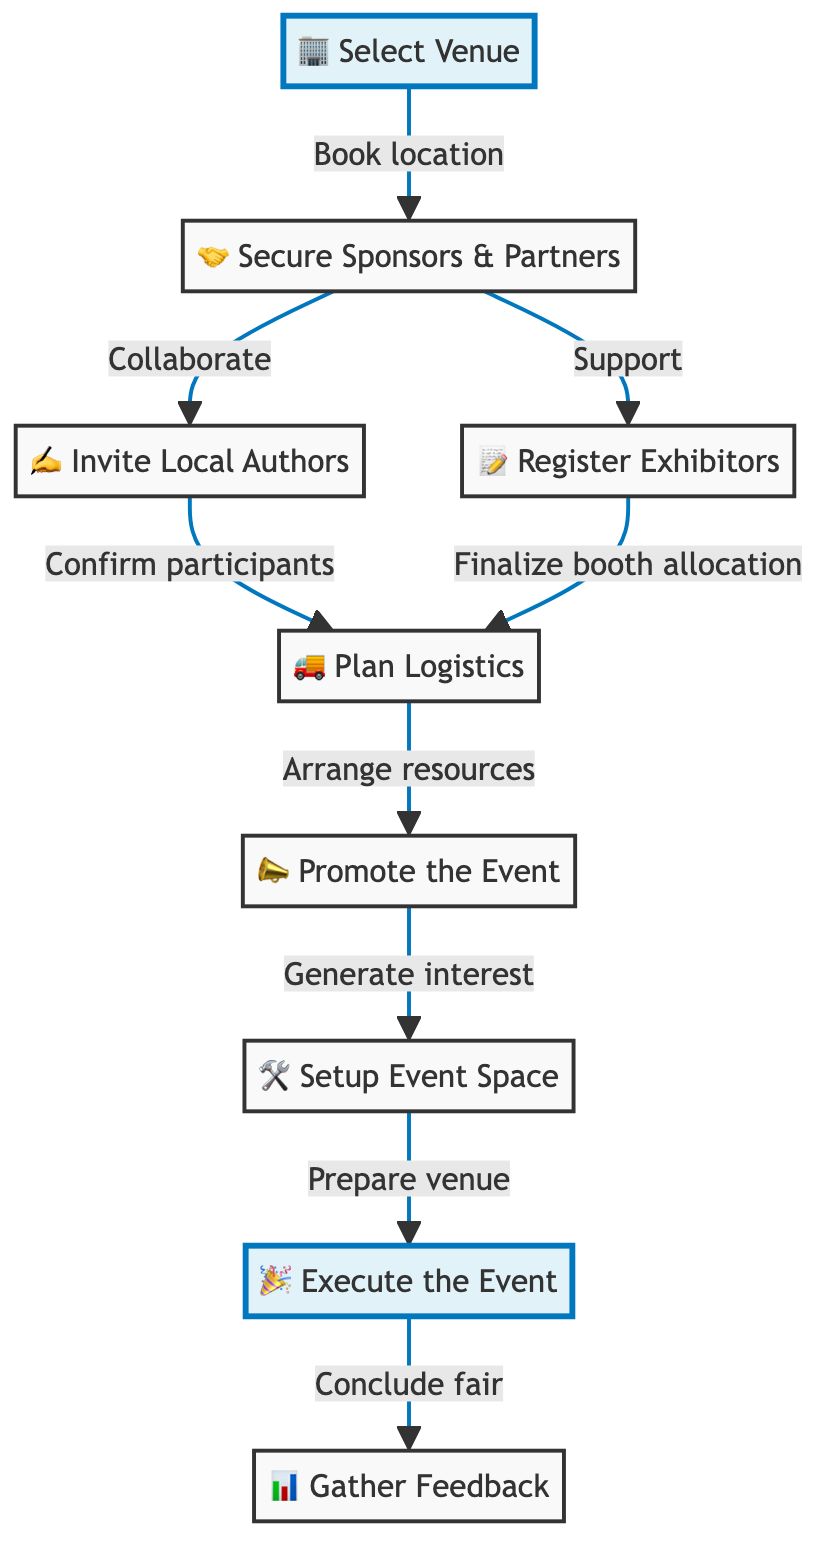What is the first step in the book fair setup process? The first step is "Select Venue," which involves identifying and booking a suitable location for the book fair.
Answer: Select Venue How many main nodes are there in the diagram? The diagram contains 9 main nodes, each representing a key step in the book fair setup process.
Answer: 9 Which step follows after securing sponsors and partners? After securing sponsors and partners, the next step is to "Invite Local Authors" to showcase their work at the fair.
Answer: Invite Local Authors What is the relationship between "Logistics Planning" and "Register Exhibitors"? Both "Logistics Planning" and "Register Exhibitors" are connected by the need to provide resources for setting up booths, indicating they occur simultaneously.
Answer: Arrange resources What is the final outcome of the event execution step? The final outcome of the "Execute the Event" step is to "Gather Feedback" from exhibitors and attendees for future improvements.
Answer: Gather Feedback Which step is highlighted in blue? The highlighted steps are "Select Venue" and "Execute the Event," indicating they are significant focal points in the process.
Answer: Select Venue, Execute the Event What is the main purpose of the "Promote the Event" step? The main purpose of the "Promote the Event" step is to generate interest in the book fair through various marketing strategies.
Answer: Generate interest What is the last action taken in the book fair setup process? The last action taken in the process is to "Gather Feedback," which helps in assessing the success of the event.
Answer: Gather Feedback 